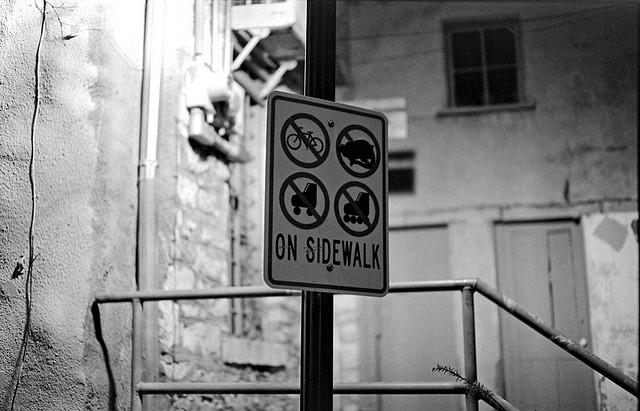What does the sign say?
Concise answer only. On sidewalk. What color is the sign?
Concise answer only. White. Is this sign in Quebec?
Answer briefly. No. Is the sign in English?
Quick response, please. Yes. What kind of wall is behind the sign?
Write a very short answer. Brick. Is this picture in color?
Answer briefly. No. Is this a city street?
Give a very brief answer. Yes. 